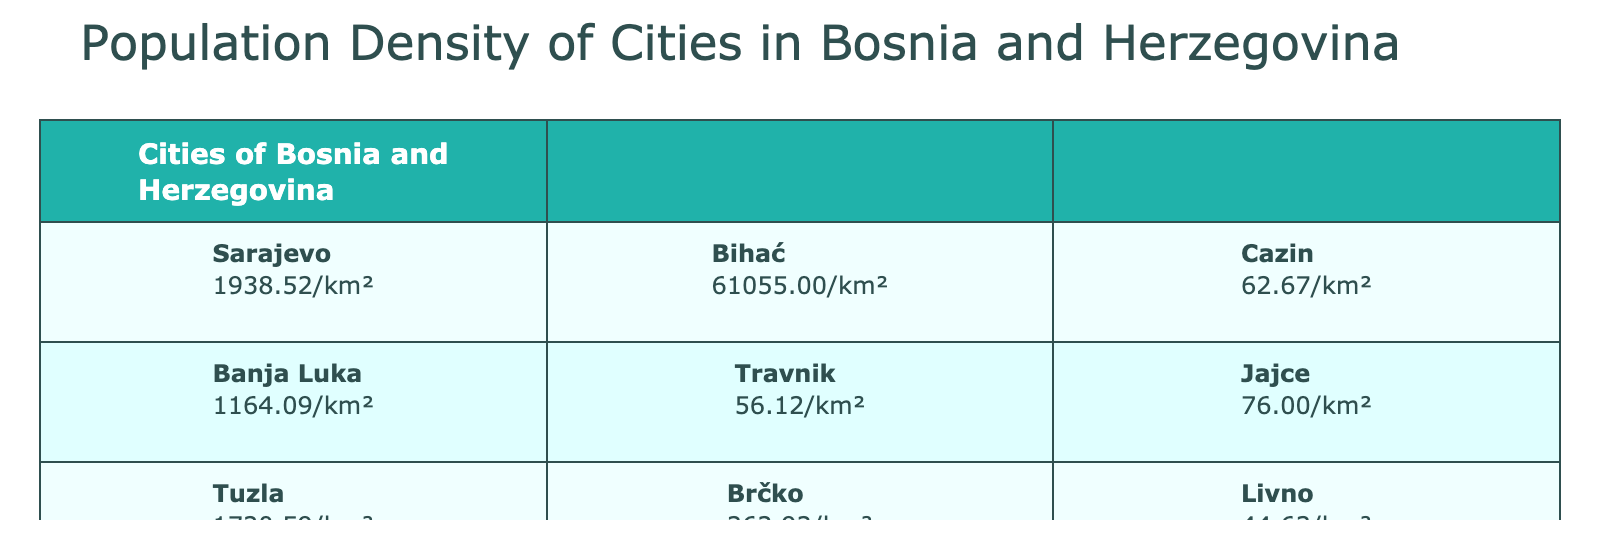What is the population density of Sarajevo? From the table, we can find the population density listed under Sarajevo. It states that the population density of Sarajevo is 1938.52 people per square kilometer.
Answer: 1938.52 Which city has the highest population density? By examining the population density values in the table, Bihać shows an exceptionally high density of 61055 people per square kilometer, which is higher than any other city listed.
Answer: Bihać What is the average population density of the cities listed? To find the average, we sum the population densities: 1938.52 + 1164.09 + 1720.59 + 1541.79 + 1529.36 + 61055 + 56.12 + 262.92 + 34.75 + 344.73 + 62.67 + 76.00 + 44.63 + 60.83 + 103.49 = 64983.01. Then we divide by the number of cities (14), which gives us 64983.01 / 14 ≈ 4641.64.
Answer: 4641.64 Does Mostar have a higher population density than Banja Luka? Comparing the population densities from the table: Mostar has a density of 1529.36, while Banja Luka has 1164.09. Since 1529.36 is greater than 1164.09, Mostar does indeed have a higher density.
Answer: Yes What is the total area of the cities with a population density greater than 1000 people per square kilometer? We identify the cities with densities over 1000: Sarajevo (142 km²), Tuzla (70 km²), Zenica (75 km²), Mostar (74 km²), and Bihać (1 km²). Adding their areas gives 142 + 70 + 75 + 74 + 1 = 362 km².
Answer: 362 What is the difference in population density between Zenica and Livno? Zenica has a population density of 1541.79, while Livno has 44.63. To find the difference, subtract Livno's density from Zenica's: 1541.79 - 44.63 = 1497.16.
Answer: 1497.16 Is the average population density of cities with a population over 100,000 greater than 1000? The cities with populations over 100,000 are Sarajevo, Banja Luka, and Tuzla. Their densities are 1938.52, 1164.09, and 1720.59 respectively. Averaging these gives (1938.52 + 1164.09 + 1720.59) / 3 = 1607.07, which is greater than 1000.
Answer: Yes What city has the smallest population density? By looking through the population densities in the table, Travnik has the smallest density at 56.12 people per square kilometer.
Answer: Travnik 